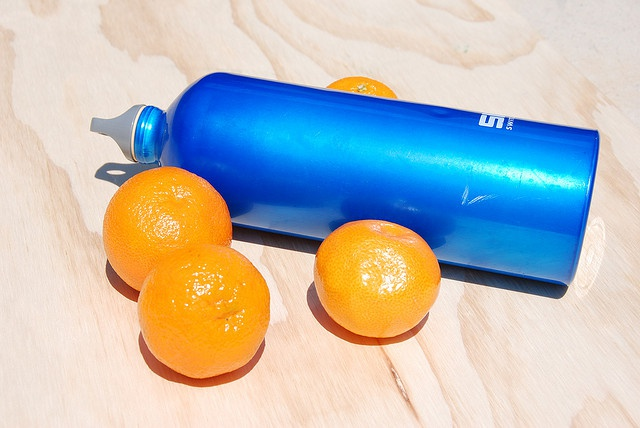Describe the objects in this image and their specific colors. I can see dining table in lightgray, orange, blue, lightblue, and tan tones, bottle in lightgray, blue, lightblue, and darkblue tones, orange in lightgray, orange, white, and tan tones, orange in lightgray, orange, gold, and ivory tones, and orange in lightgray, orange, red, and tan tones in this image. 